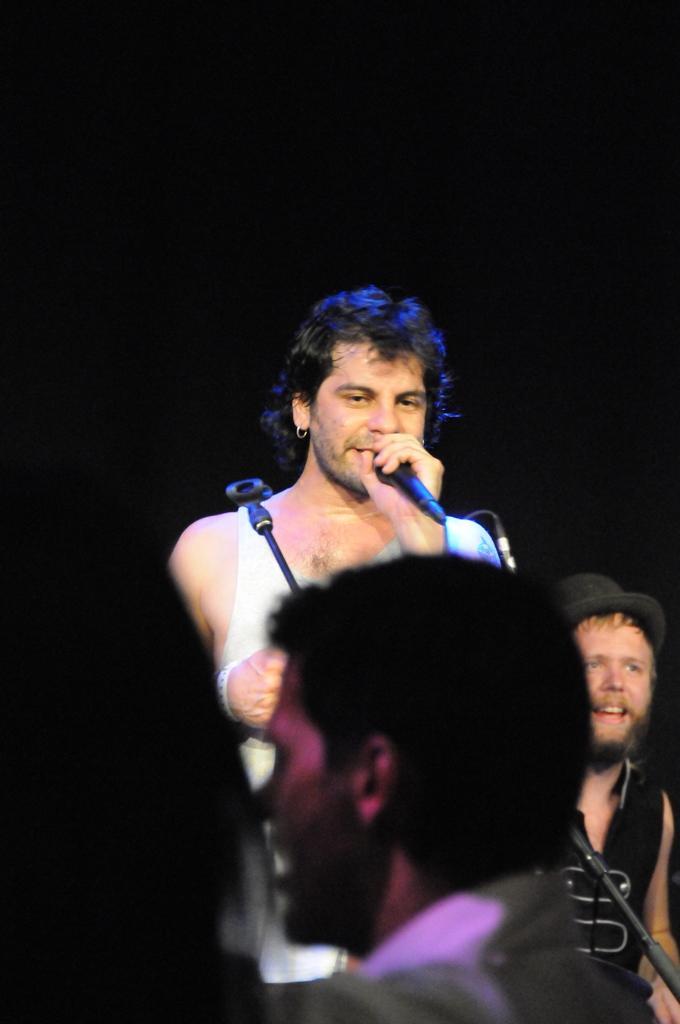Please provide a concise description of this image. In this image we have a man standing and singing a song in the microphone and in the back ground we have a person smiling and some group of people. 